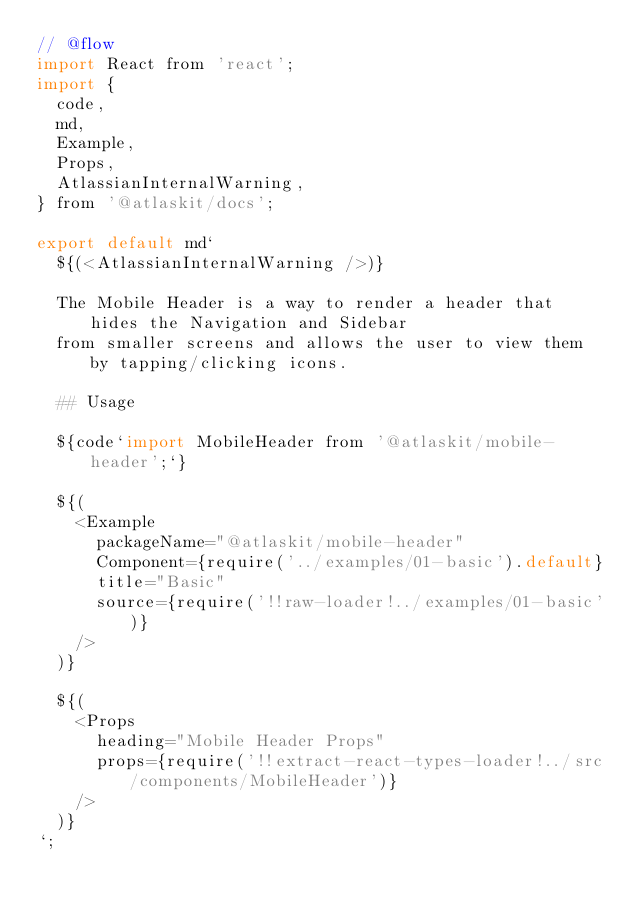<code> <loc_0><loc_0><loc_500><loc_500><_JavaScript_>// @flow
import React from 'react';
import {
  code,
  md,
  Example,
  Props,
  AtlassianInternalWarning,
} from '@atlaskit/docs';

export default md`
  ${(<AtlassianInternalWarning />)}
  
  The Mobile Header is a way to render a header that hides the Navigation and Sidebar
  from smaller screens and allows the user to view them by tapping/clicking icons.

  ## Usage

  ${code`import MobileHeader from '@atlaskit/mobile-header';`}

  ${(
    <Example
      packageName="@atlaskit/mobile-header"
      Component={require('../examples/01-basic').default}
      title="Basic"
      source={require('!!raw-loader!../examples/01-basic')}
    />
  )}

  ${(
    <Props
      heading="Mobile Header Props"
      props={require('!!extract-react-types-loader!../src/components/MobileHeader')}
    />
  )}
`;
</code> 